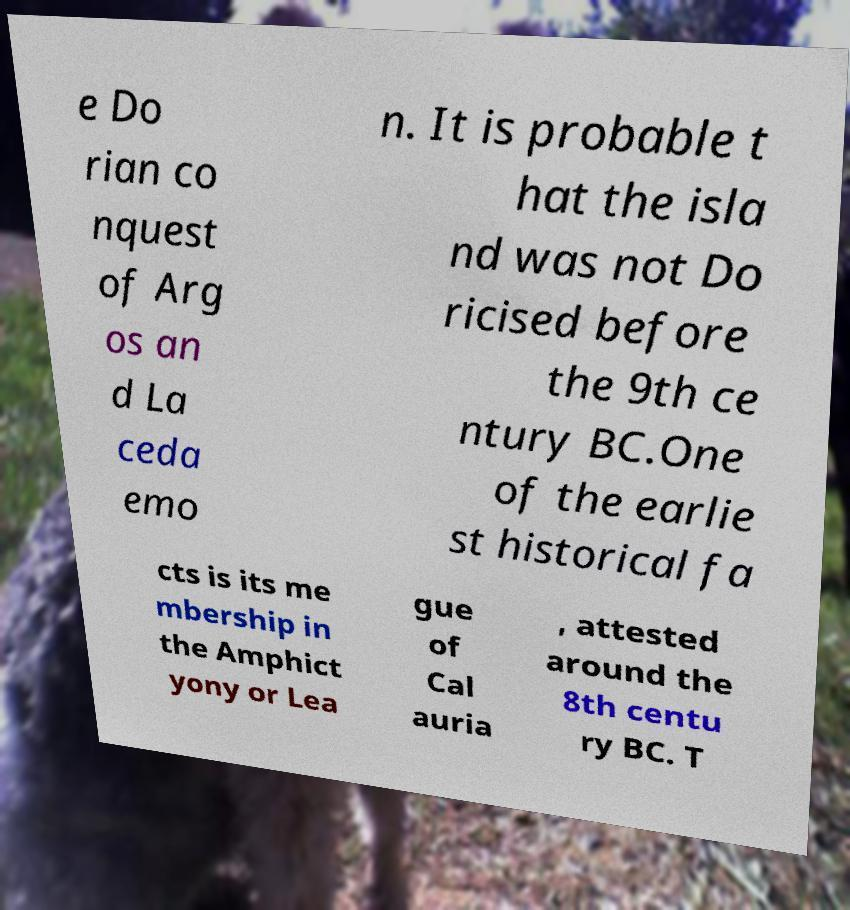What messages or text are displayed in this image? I need them in a readable, typed format. e Do rian co nquest of Arg os an d La ceda emo n. It is probable t hat the isla nd was not Do ricised before the 9th ce ntury BC.One of the earlie st historical fa cts is its me mbership in the Amphict yony or Lea gue of Cal auria , attested around the 8th centu ry BC. T 